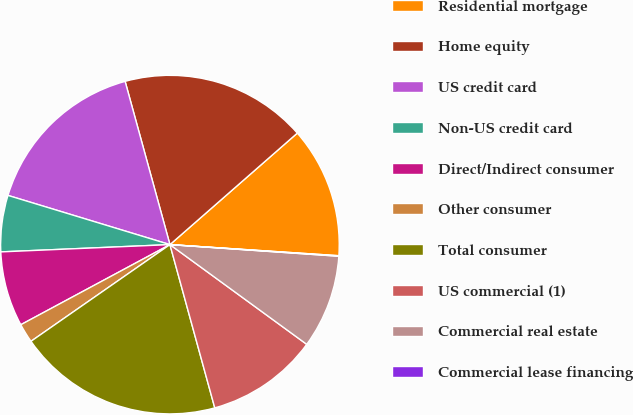Convert chart. <chart><loc_0><loc_0><loc_500><loc_500><pie_chart><fcel>Residential mortgage<fcel>Home equity<fcel>US credit card<fcel>Non-US credit card<fcel>Direct/Indirect consumer<fcel>Other consumer<fcel>Total consumer<fcel>US commercial (1)<fcel>Commercial real estate<fcel>Commercial lease financing<nl><fcel>12.49%<fcel>17.82%<fcel>16.04%<fcel>5.38%<fcel>7.16%<fcel>1.83%<fcel>19.59%<fcel>10.71%<fcel>8.93%<fcel>0.05%<nl></chart> 